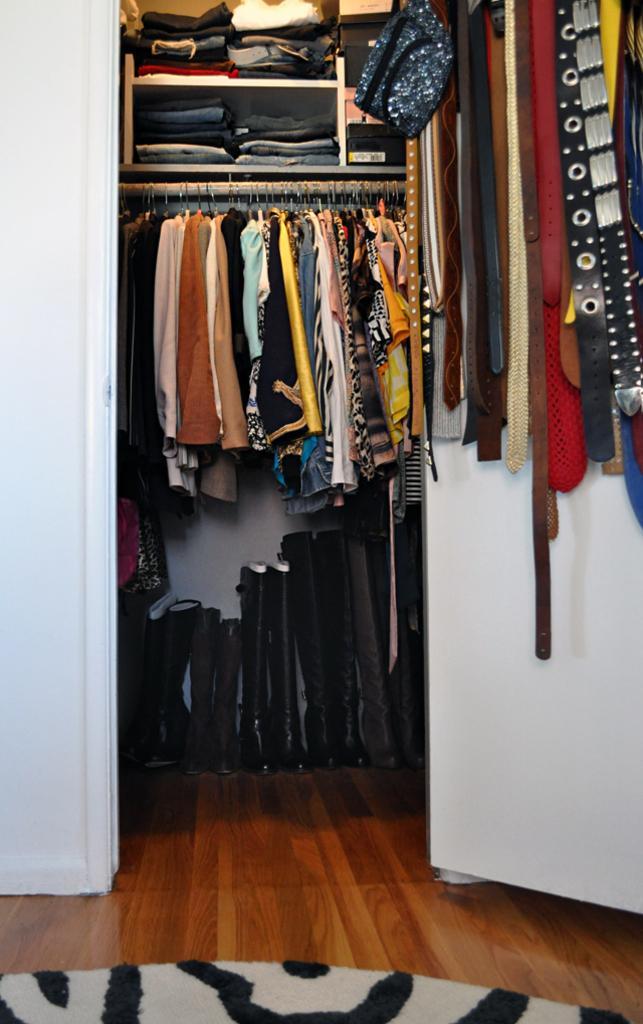How would you summarize this image in a sentence or two? In this image we can see wardrobe which includes, clothes, shelf unit, on the right we can see belts, at the bottom we can see wooden floor and floor mat. 